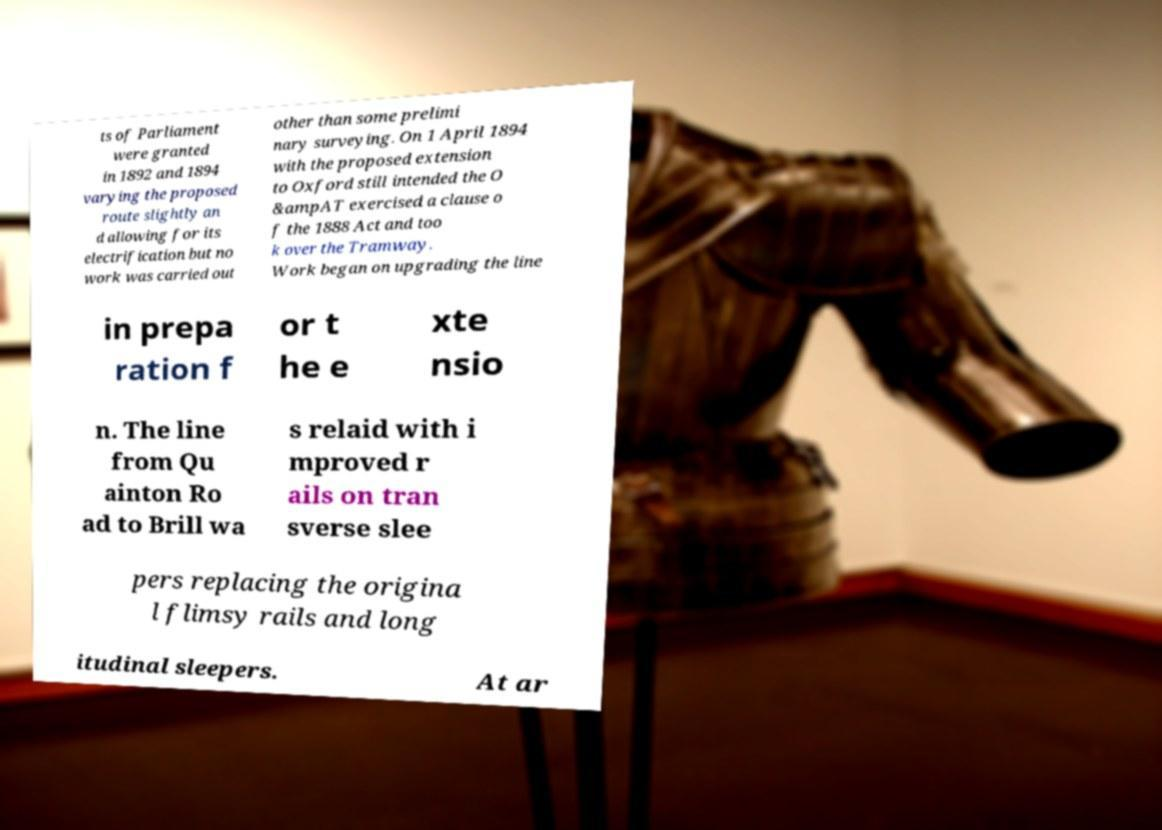Could you extract and type out the text from this image? ts of Parliament were granted in 1892 and 1894 varying the proposed route slightly an d allowing for its electrification but no work was carried out other than some prelimi nary surveying. On 1 April 1894 with the proposed extension to Oxford still intended the O &ampAT exercised a clause o f the 1888 Act and too k over the Tramway. Work began on upgrading the line in prepa ration f or t he e xte nsio n. The line from Qu ainton Ro ad to Brill wa s relaid with i mproved r ails on tran sverse slee pers replacing the origina l flimsy rails and long itudinal sleepers. At ar 